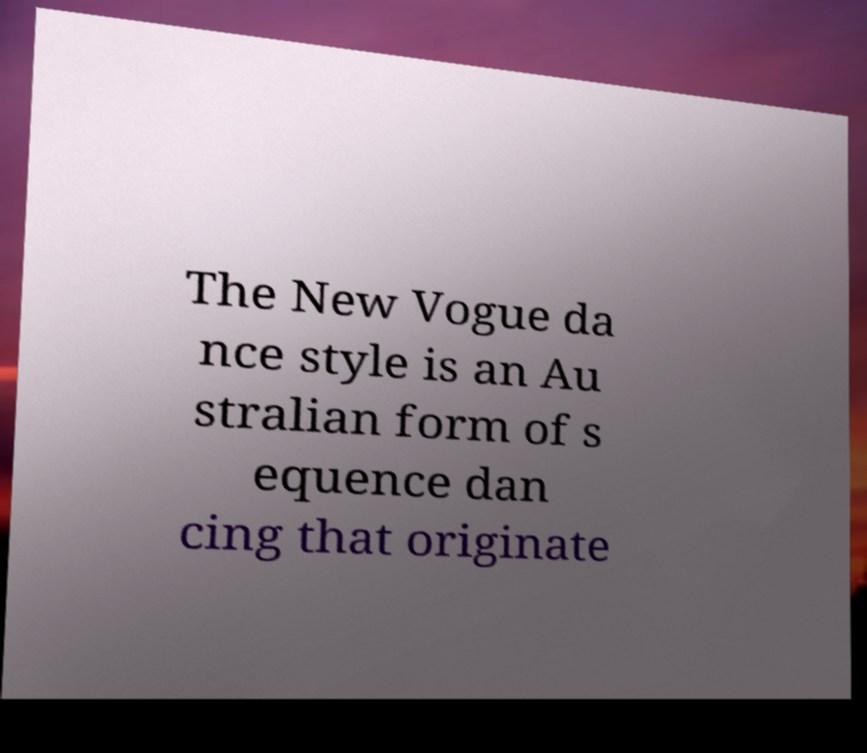For documentation purposes, I need the text within this image transcribed. Could you provide that? The New Vogue da nce style is an Au stralian form of s equence dan cing that originate 